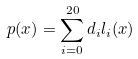<formula> <loc_0><loc_0><loc_500><loc_500>p ( x ) = \sum _ { i = 0 } ^ { 2 0 } d _ { i } l _ { i } ( x )</formula> 